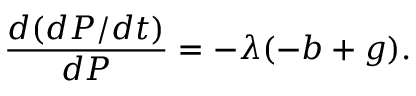<formula> <loc_0><loc_0><loc_500><loc_500>{ \frac { d ( d P / d t ) } { d P } } = - \lambda ( - b + g ) .</formula> 